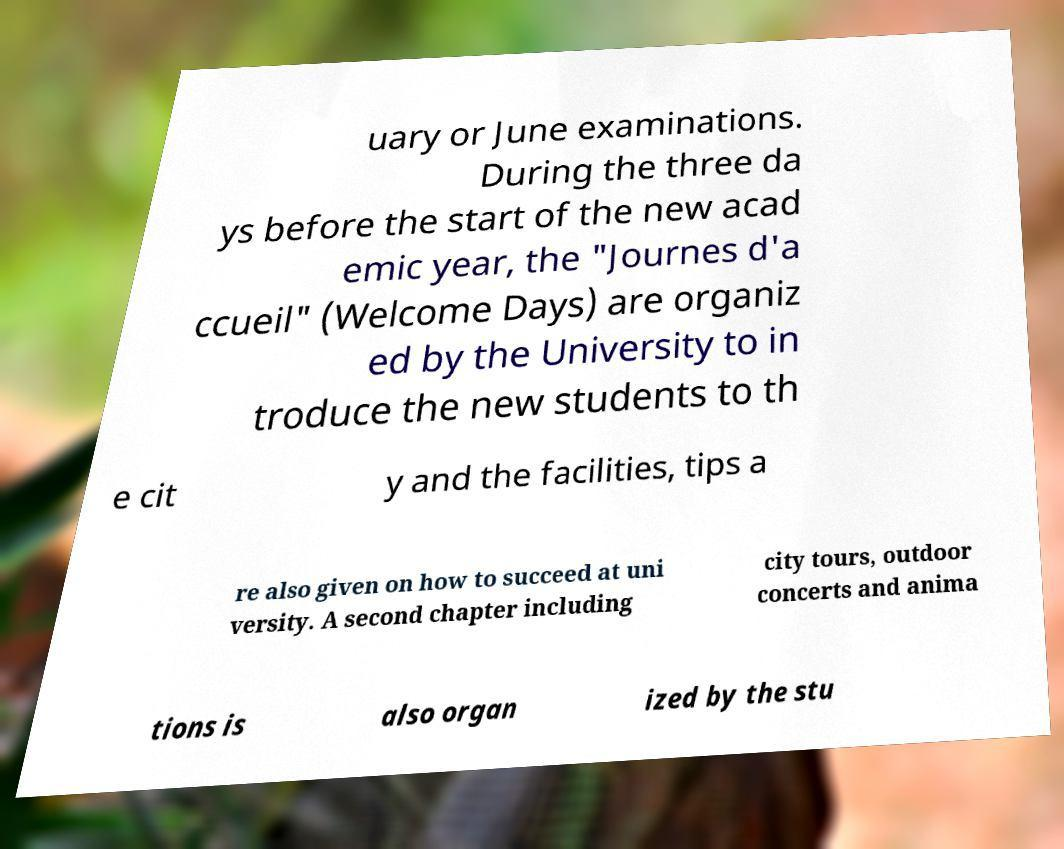Please identify and transcribe the text found in this image. uary or June examinations. During the three da ys before the start of the new acad emic year, the "Journes d'a ccueil" (Welcome Days) are organiz ed by the University to in troduce the new students to th e cit y and the facilities, tips a re also given on how to succeed at uni versity. A second chapter including city tours, outdoor concerts and anima tions is also organ ized by the stu 